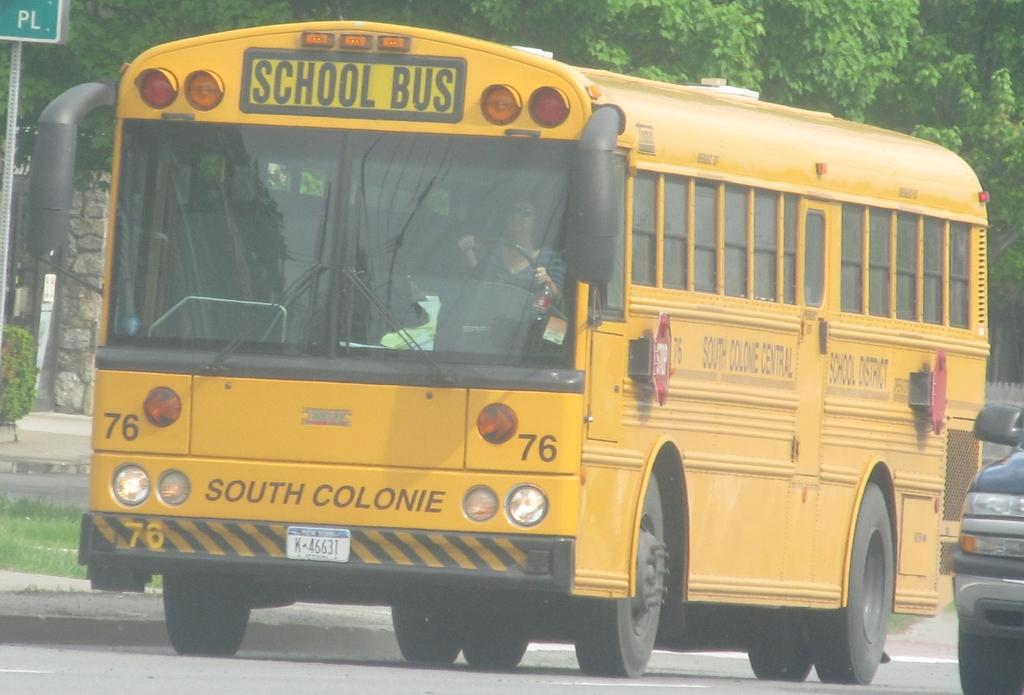<image>
Offer a succinct explanation of the picture presented. A big yellow school bus is going to South Colonie. 